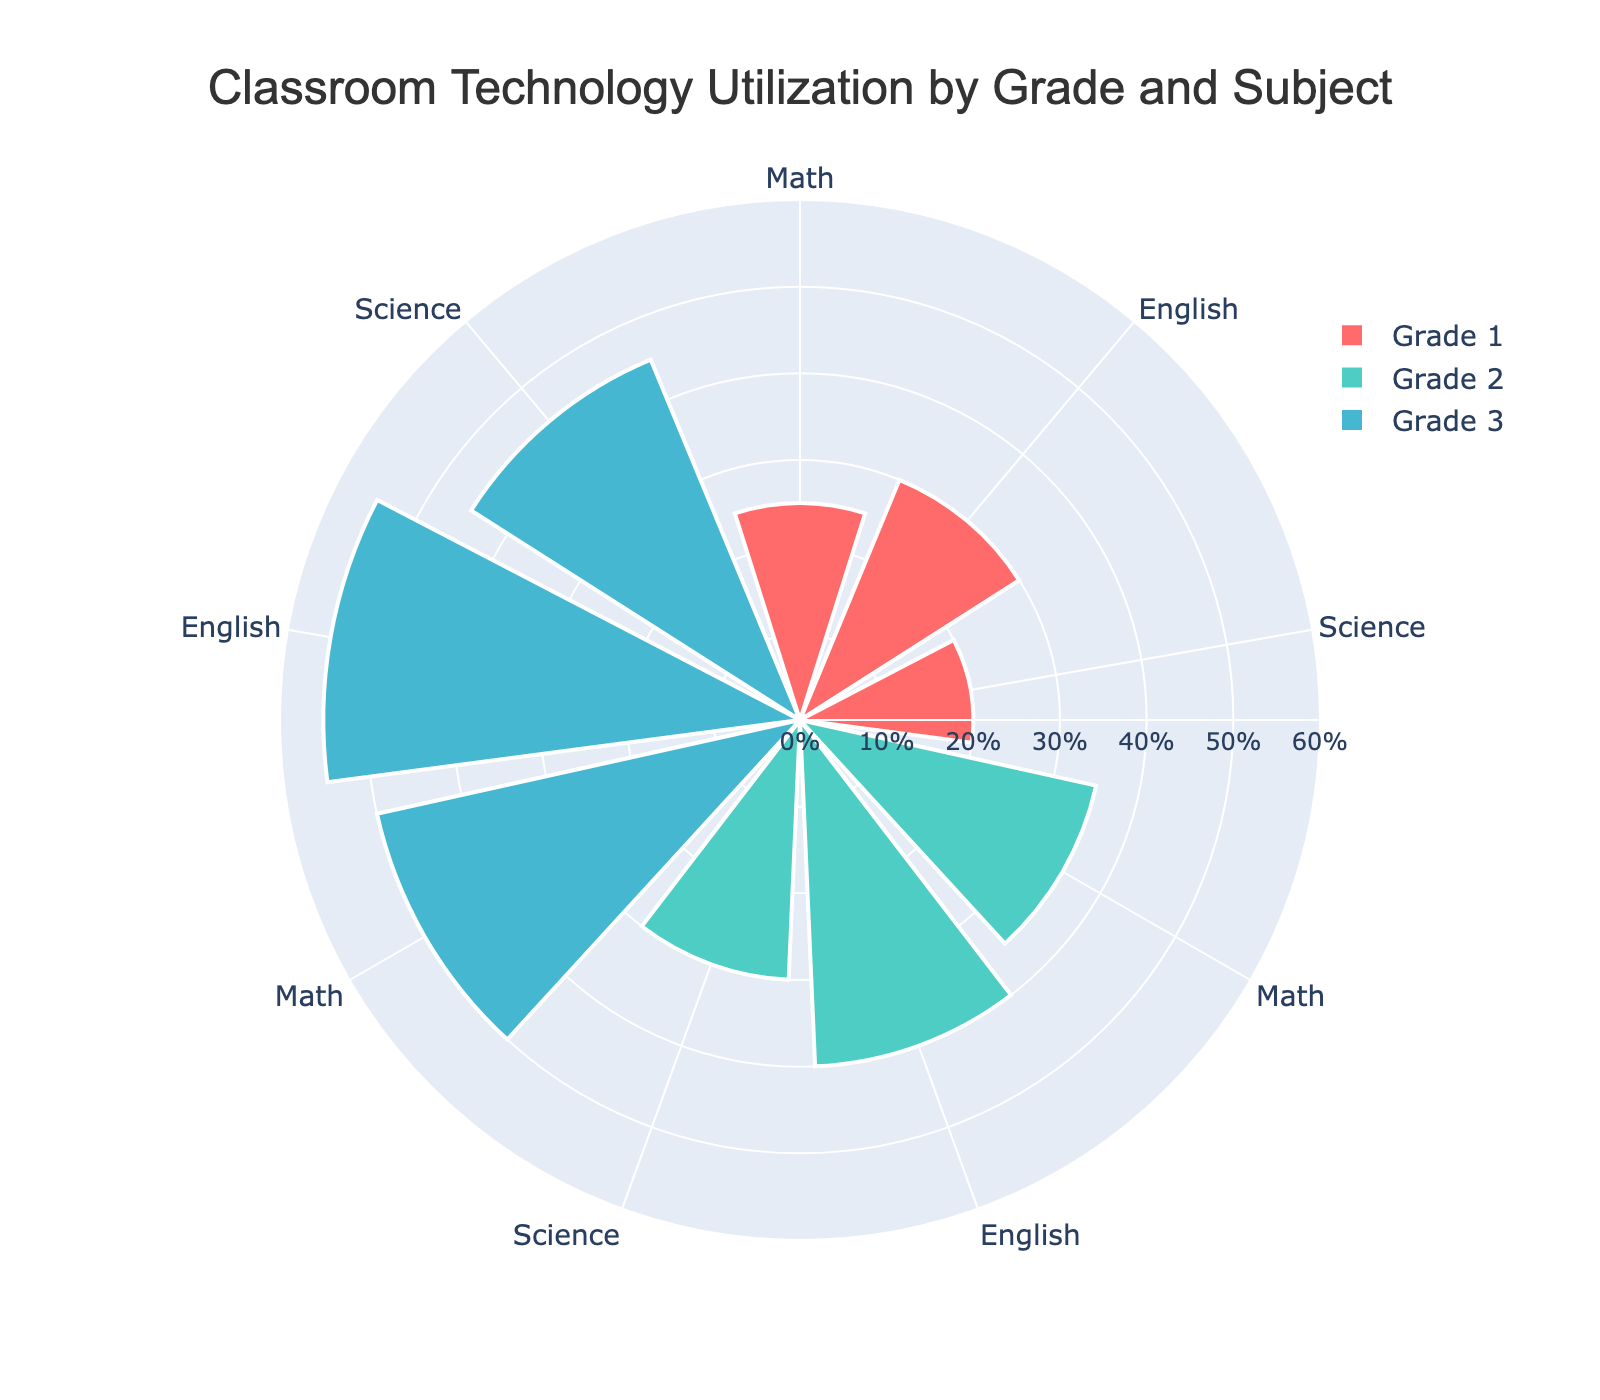What's the highest percentage of technology utilization in Grade 1? The highest percentage for Grade 1 can be observed by comparing the lengths of the bars for Math, English, and Science. English, at 30%, has the highest usage.
Answer: 30% What's the average percentage of technology utilization across all subjects in Grade 2? To find the average, add the utilization percentages for Math (35%), English (40%), and Science (30%) and divide by the number of subjects: (35 + 40 + 30) / 3 = 35%.
Answer: 35% How does the utilization of technology in English differ between Grade 1 and Grade 3? The utilization for English in Grade 1 is 30%, and for Grade 3, it is 55%. The difference is 55% - 30% = 25%.
Answer: 25% In which subject of Grade 3 is technology utilized the least? By comparing the bar lengths for Math, English, and Science in Grade 3, we see that Science has the lowest utilization at 45%.
Answer: Science What is the total percentage of technology utilization in Math across all grades? Add the utilization percentages for Math in all grades: 25% (Grade 1) + 35% (Grade 2) + 50% (Grade 3) = 110%.
Answer: 110% Do any Grades have the same percentage of technology utilization in any subject? A quick look through the subjects and corresponding grades shows that there are no subjects with the same utilization percentage across different grades.
Answer: No Which Grade has the highest overall technology utilization average across all subjects? Calculate the average for each grade: Grade 1: (25 + 30 + 20) / 3 = 25%; Grade 2: (35 + 40 + 30) / 3 = 35%; Grade 3: (50 + 55 + 45) / 3 ≈ 50%. Grade 3 has the highest average.
Answer: Grade 3 How many different color categories are used in the chart? By observing the chart, you can see that there are three distinct colors used, one for each grade.
Answer: 3 What is the utilization difference in Science between Grade 1 and Grade 2? Compare the Science utilization percentages: Grade 1 is 20% and Grade 2 is 30%, so the difference is 30% - 20% = 10%.
Answer: 10% Which subject shows the most significant increase in technology utilization from Grade 1 to Grade 3? Comparing the differences in utilization from Grade 1 to Grade 3 for each subject: Math (50% - 25% = 25%), English (55% - 30% = 25%), Science (45% - 20% = 25%). All subjects show a 25% increase.
Answer: All subjects 